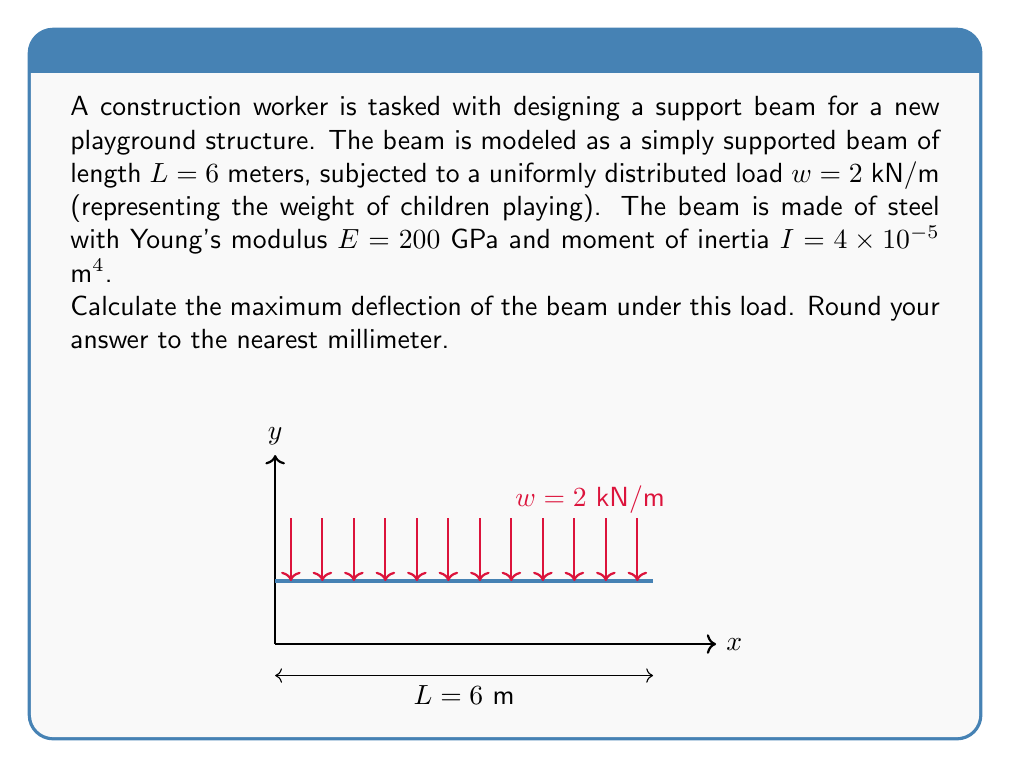Help me with this question. To solve this problem, we'll use the formula for maximum deflection of a simply supported beam under uniformly distributed load:

$$y_{max} = \frac{5wL^4}{384EI}$$

Where:
- $y_{max}$ is the maximum deflection
- $w$ is the uniformly distributed load
- $L$ is the length of the beam
- $E$ is Young's modulus
- $I$ is the moment of inertia

Step 1: Substitute the given values into the equation:
$$y_{max} = \frac{5 \cdot (2000 \text{ N/m}) \cdot (6 \text{ m})^4}{384 \cdot (200 \times 10^9 \text{ Pa}) \cdot (4 \times 10^{-5} \text{ m}^4)}$$

Step 2: Simplify the numerator:
$$y_{max} = \frac{5 \cdot 2000 \cdot 1296}{384 \cdot (200 \times 10^9) \cdot (4 \times 10^{-5})}$$

Step 3: Calculate:
$$y_{max} = \frac{12,960,000}{30,720,000,000,000} = 0.000421875 \text{ m}$$

Step 4: Convert to millimeters and round to the nearest millimeter:
$$y_{max} = 0.000421875 \text{ m} \cdot \frac{1000 \text{ mm}}{1 \text{ m}} \approx 0.422 \text{ mm}$$

Rounding to the nearest millimeter gives us 0 mm.
Answer: 0 mm 